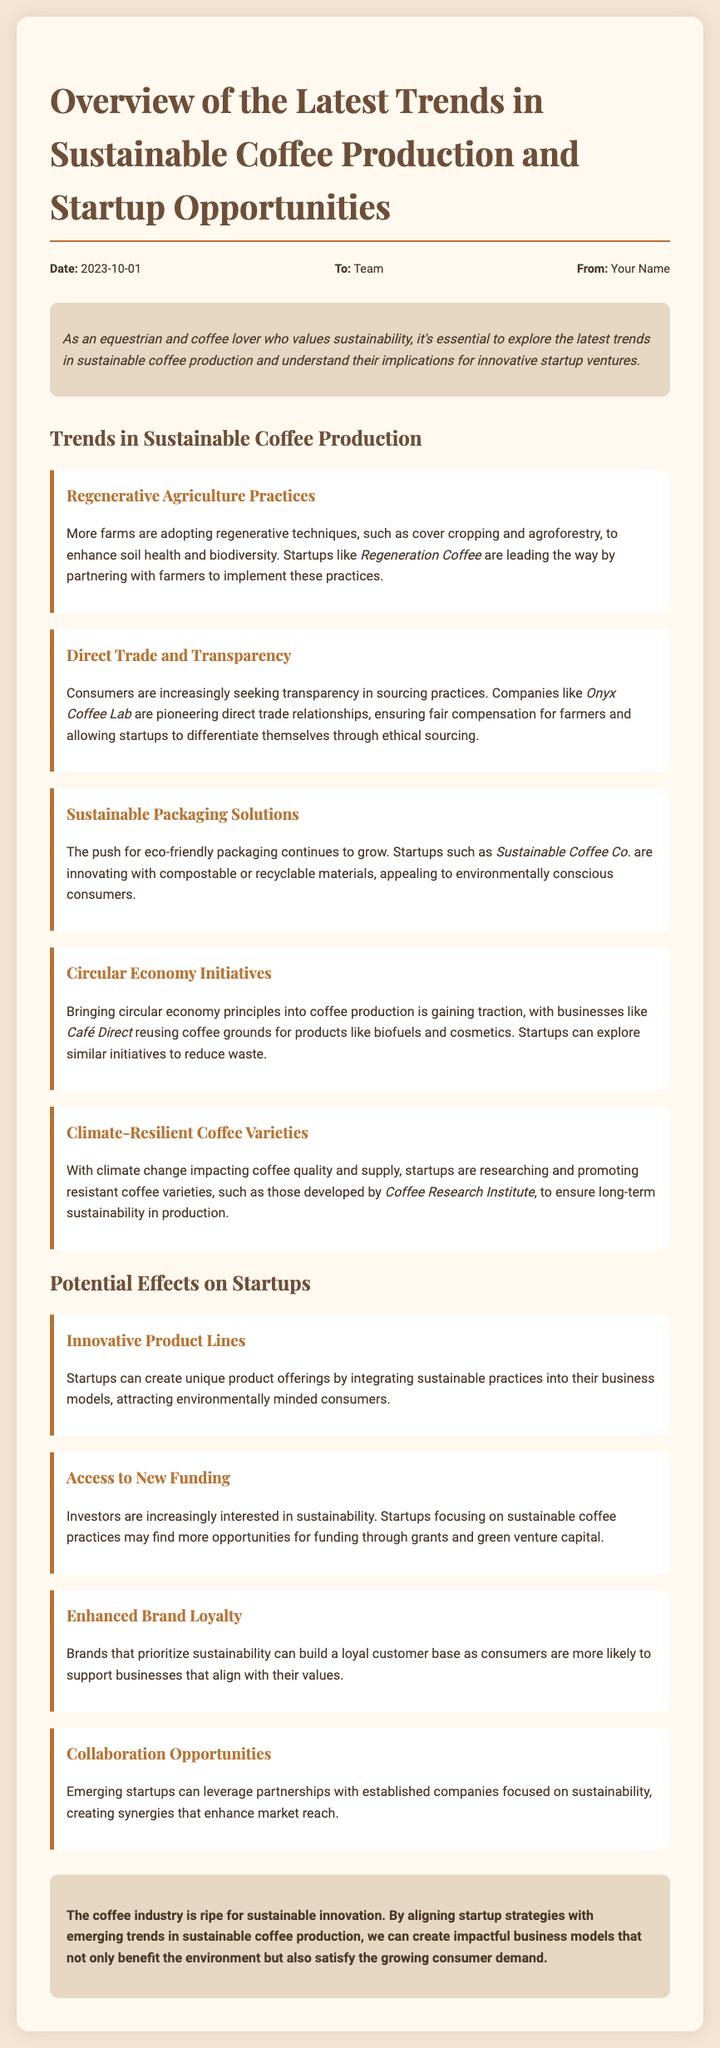What are regenerative agriculture practices? This term is defined in the trends section, where it refers to techniques like cover cropping and agroforestry for enhancing soil health and biodiversity.
Answer: cover cropping and agroforestry Which company is highlighted for direct trade relationships? The document states that Onyx Coffee Lab is pioneering direct trade relationships.
Answer: Onyx Coffee Lab When was the memo written? The date provided in the memo is clearly indicated in the meta-info section.
Answer: 2023-10-01 What are some examples of sustainable packaging solutions mentioned? The memo references startups innovating with compostable or recyclable materials under the trend of sustainable packaging solutions.
Answer: compostable or recyclable materials What potential effect on startups relates to attracting a customer base? The document mentions enhanced brand loyalty as a potential effect on startups’ strategies related to sustainability.
Answer: Enhanced Brand Loyalty How can startups explore waste reduction initiatives? The document suggests that startups can look into similar initiatives as Café Direct, which reuses coffee grounds for various products.
Answer: Cafe Direct What trend is associated with climate change in coffee production? The memo discusses climate-resilient coffee varieties as a response to the impacts of climate change on coffee supply and quality.
Answer: climate-resilient coffee varieties What is the focus of the document? The memo provides an overview of trends in sustainable coffee production and their implications on startup opportunities within the coffee industry.
Answer: Trends in sustainable coffee production and startup opportunities How are investors shown to view sustainability? The document indicates that investors are increasingly interested in sustainability, which may lead to more funding opportunities for startups focusing on sustainable coffee.
Answer: increasingly interested in sustainability 